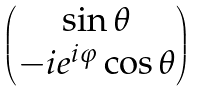<formula> <loc_0><loc_0><loc_500><loc_500>\begin{pmatrix} \sin \theta \\ - i e ^ { i \varphi } \cos \theta \end{pmatrix}</formula> 